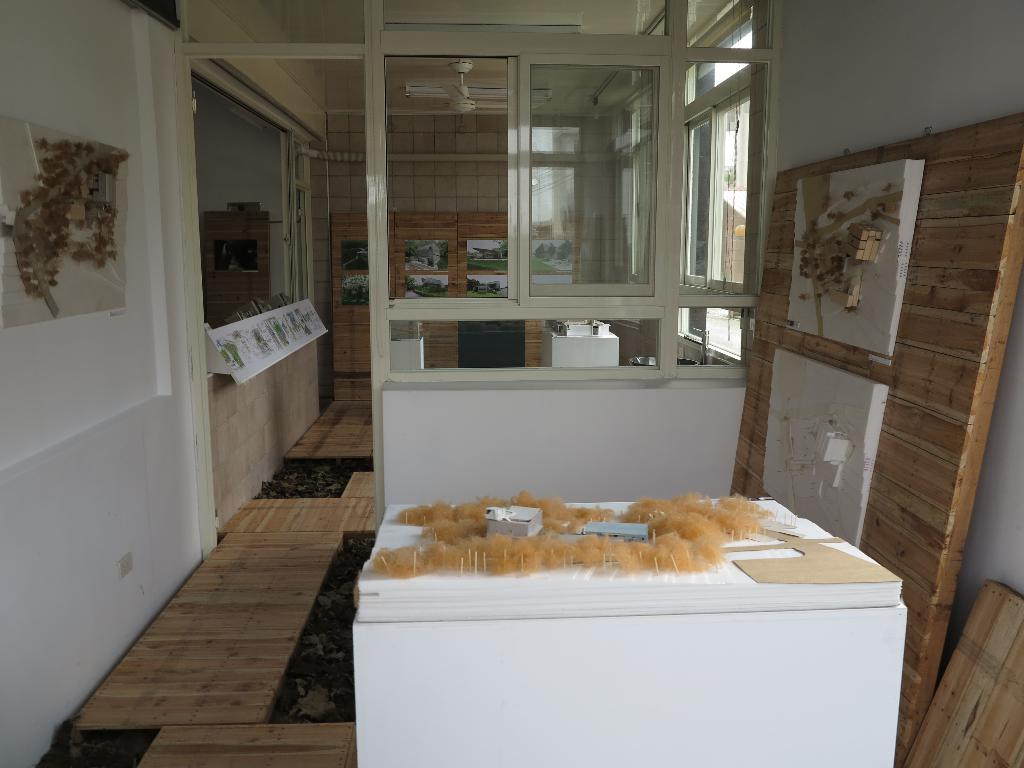What type of surface can be seen in the image? There is a counter in the image. What is the background of the image made of? There is a wall in the image. What allows natural light to enter the room in the image? There are windows in the image. What device is present for air circulation in the image? There is a fan in the image. What type of decoration is present on the wall in the image? There are wall paintings in the image. In which type of space is the image taken? The image is taken in a room. What type of kite can be seen flying in the image? There is no kite present in the image. What type of cast is visible on the wall in the image? There is no cast present in the image. 